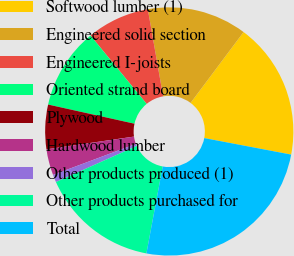<chart> <loc_0><loc_0><loc_500><loc_500><pie_chart><fcel>Softwood lumber (1)<fcel>Engineered solid section<fcel>Engineered I-joists<fcel>Oriented strand board<fcel>Plywood<fcel>Hardwood lumber<fcel>Other products produced (1)<fcel>Other products purchased for<fcel>Total<nl><fcel>17.77%<fcel>12.98%<fcel>8.18%<fcel>10.58%<fcel>5.78%<fcel>3.39%<fcel>0.99%<fcel>15.37%<fcel>24.96%<nl></chart> 